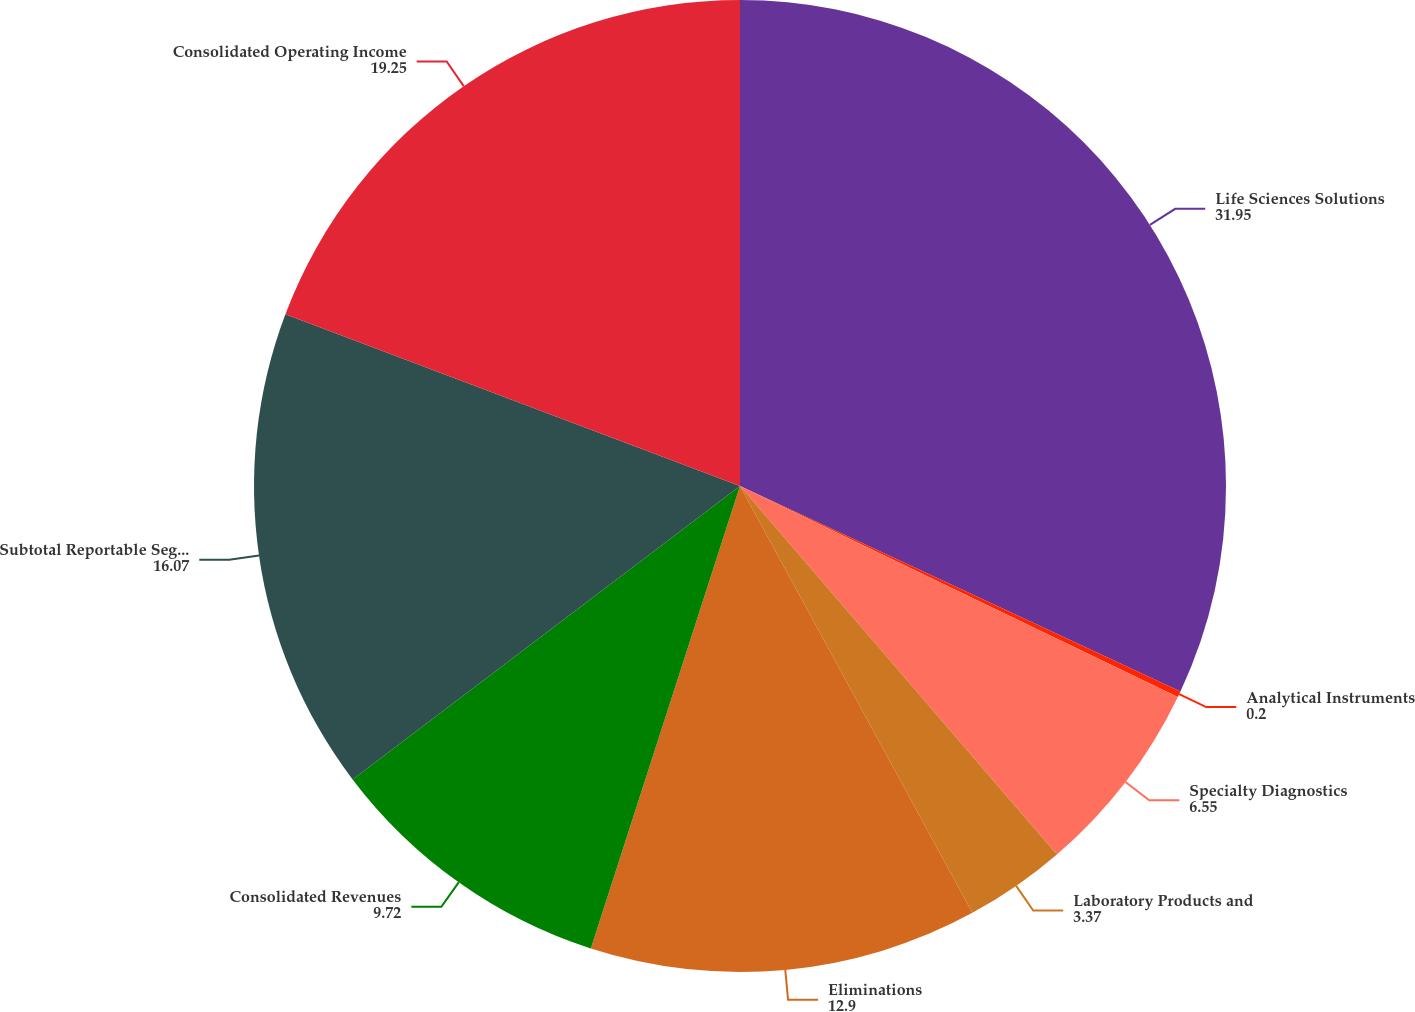Convert chart to OTSL. <chart><loc_0><loc_0><loc_500><loc_500><pie_chart><fcel>Life Sciences Solutions<fcel>Analytical Instruments<fcel>Specialty Diagnostics<fcel>Laboratory Products and<fcel>Eliminations<fcel>Consolidated Revenues<fcel>Subtotal Reportable Segments<fcel>Consolidated Operating Income<nl><fcel>31.95%<fcel>0.2%<fcel>6.55%<fcel>3.37%<fcel>12.9%<fcel>9.72%<fcel>16.07%<fcel>19.25%<nl></chart> 